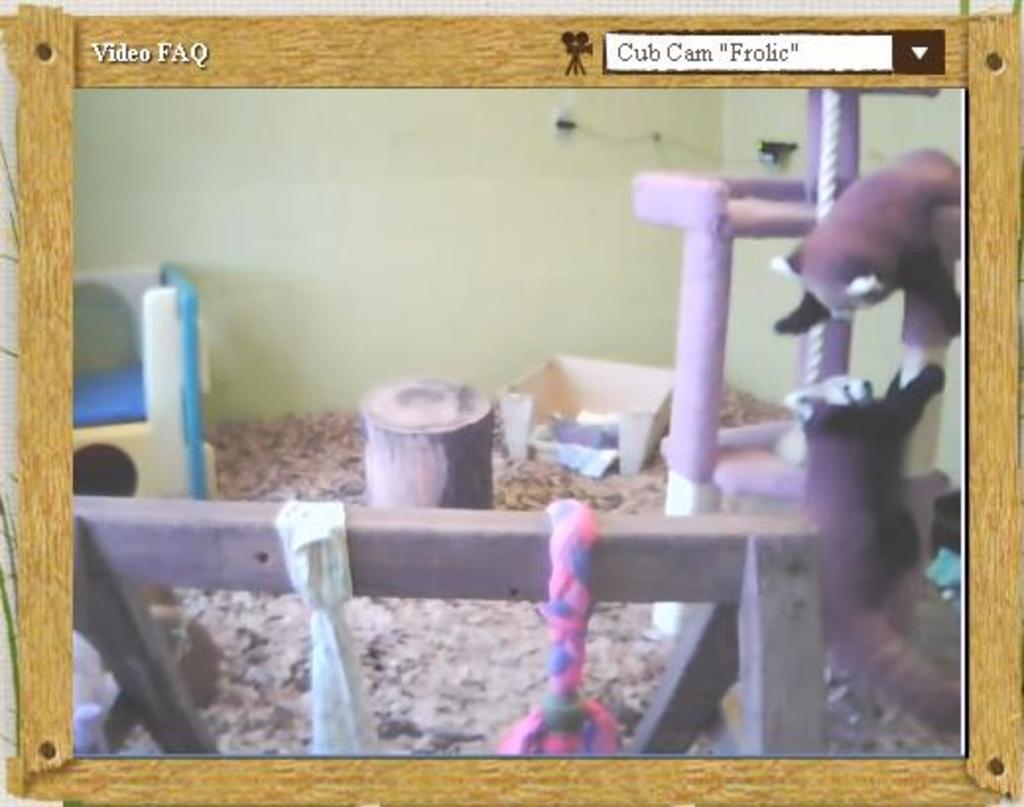Describe this image in one or two sentences. In this picture there is a poster in the center of the image. 